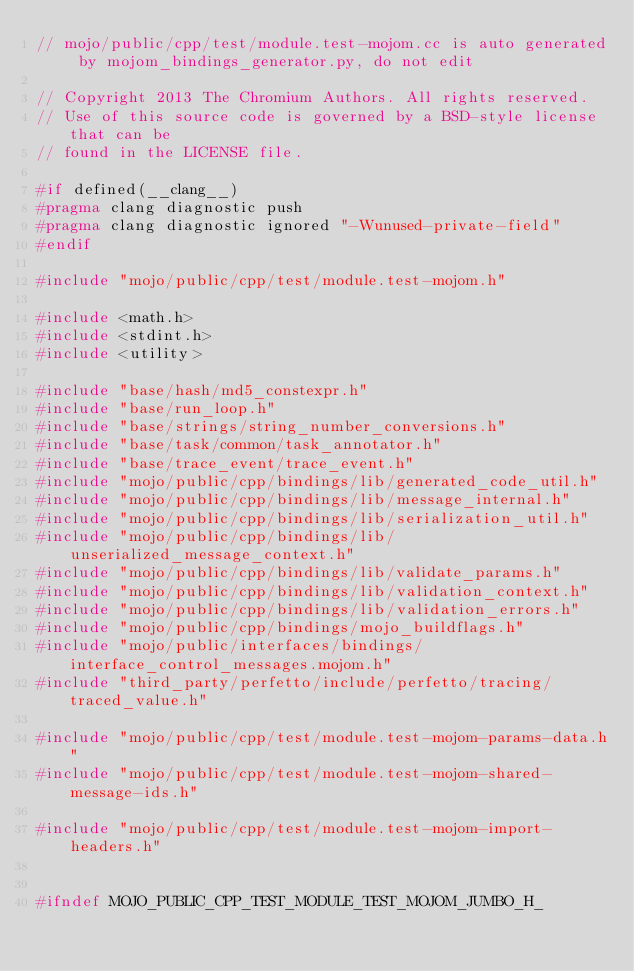<code> <loc_0><loc_0><loc_500><loc_500><_C++_>// mojo/public/cpp/test/module.test-mojom.cc is auto generated by mojom_bindings_generator.py, do not edit

// Copyright 2013 The Chromium Authors. All rights reserved.
// Use of this source code is governed by a BSD-style license that can be
// found in the LICENSE file.

#if defined(__clang__)
#pragma clang diagnostic push
#pragma clang diagnostic ignored "-Wunused-private-field"
#endif

#include "mojo/public/cpp/test/module.test-mojom.h"

#include <math.h>
#include <stdint.h>
#include <utility>

#include "base/hash/md5_constexpr.h"
#include "base/run_loop.h"
#include "base/strings/string_number_conversions.h"
#include "base/task/common/task_annotator.h"
#include "base/trace_event/trace_event.h"
#include "mojo/public/cpp/bindings/lib/generated_code_util.h"
#include "mojo/public/cpp/bindings/lib/message_internal.h"
#include "mojo/public/cpp/bindings/lib/serialization_util.h"
#include "mojo/public/cpp/bindings/lib/unserialized_message_context.h"
#include "mojo/public/cpp/bindings/lib/validate_params.h"
#include "mojo/public/cpp/bindings/lib/validation_context.h"
#include "mojo/public/cpp/bindings/lib/validation_errors.h"
#include "mojo/public/cpp/bindings/mojo_buildflags.h"
#include "mojo/public/interfaces/bindings/interface_control_messages.mojom.h"
#include "third_party/perfetto/include/perfetto/tracing/traced_value.h"

#include "mojo/public/cpp/test/module.test-mojom-params-data.h"
#include "mojo/public/cpp/test/module.test-mojom-shared-message-ids.h"

#include "mojo/public/cpp/test/module.test-mojom-import-headers.h"


#ifndef MOJO_PUBLIC_CPP_TEST_MODULE_TEST_MOJOM_JUMBO_H_</code> 